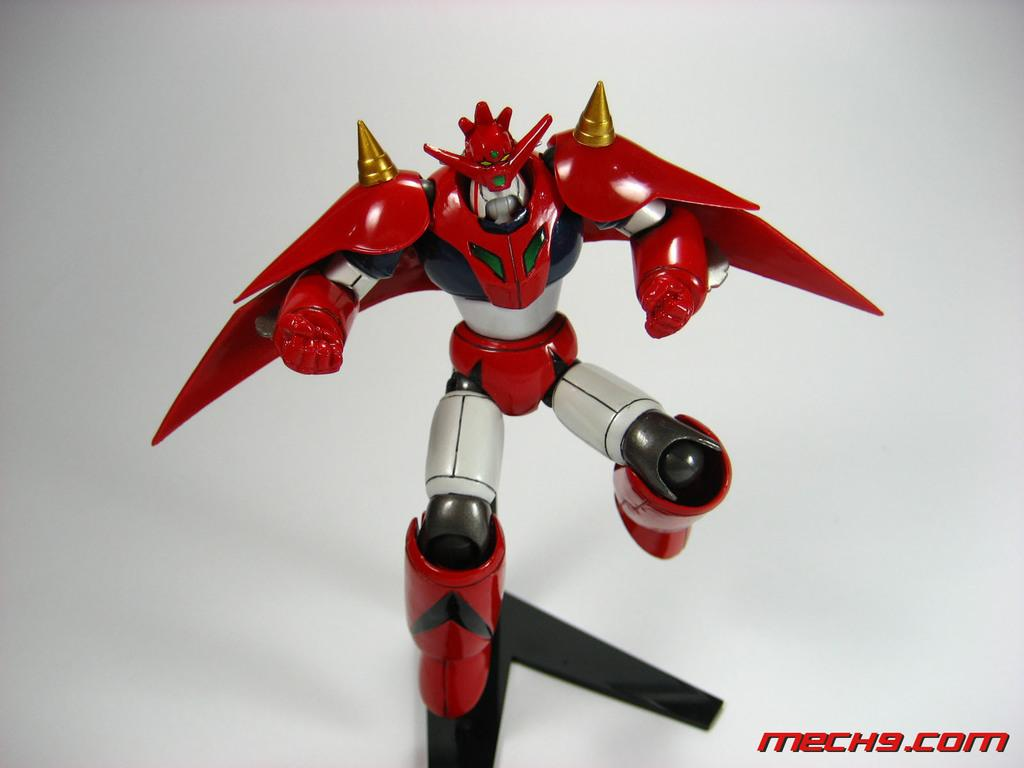What is the main subject of the image? There is a robot in the image. What else can be seen in the image besides the robot? There is text in the image. How would you describe the background of the image? The background of the image is ash colored. What type of destruction is the tramp causing in the image? There is no tramp or destruction present in the image; it features a robot and text against an ash-colored background. 